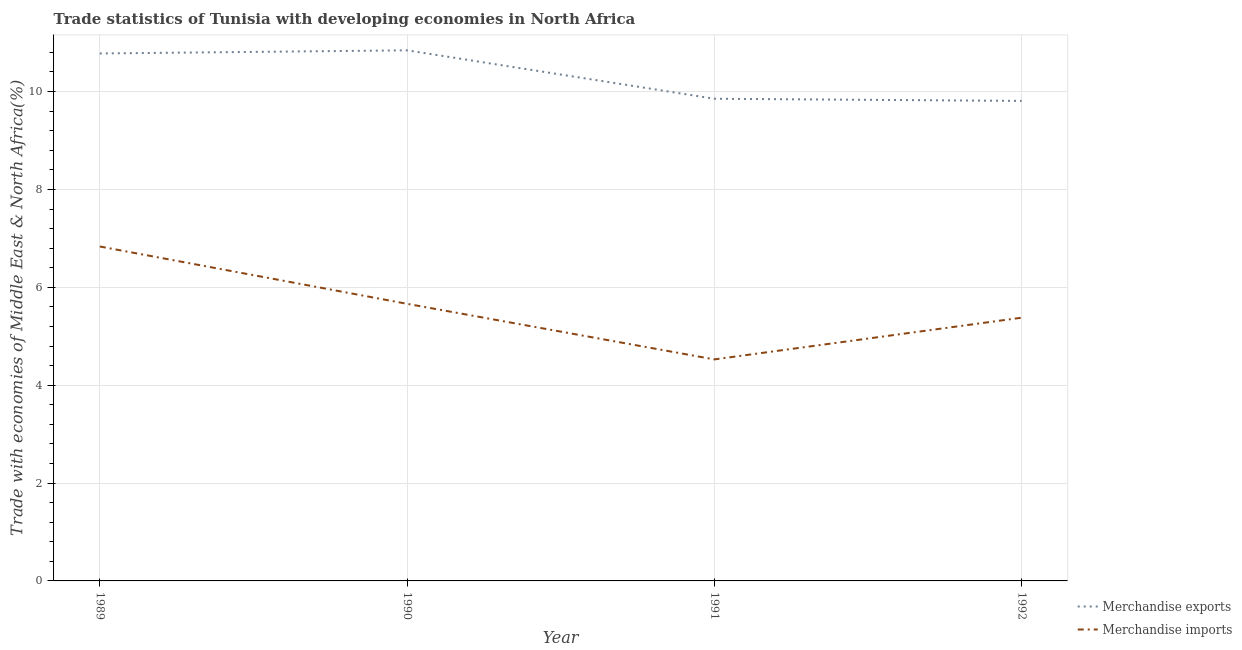What is the merchandise imports in 1991?
Keep it short and to the point. 4.53. Across all years, what is the maximum merchandise imports?
Give a very brief answer. 6.83. Across all years, what is the minimum merchandise exports?
Ensure brevity in your answer.  9.81. In which year was the merchandise imports maximum?
Your answer should be compact. 1989. In which year was the merchandise imports minimum?
Keep it short and to the point. 1991. What is the total merchandise imports in the graph?
Keep it short and to the point. 22.4. What is the difference between the merchandise imports in 1991 and that in 1992?
Offer a terse response. -0.85. What is the difference between the merchandise imports in 1991 and the merchandise exports in 1990?
Offer a very short reply. -6.32. What is the average merchandise exports per year?
Offer a very short reply. 10.32. In the year 1989, what is the difference between the merchandise imports and merchandise exports?
Keep it short and to the point. -3.94. What is the ratio of the merchandise imports in 1989 to that in 1992?
Offer a very short reply. 1.27. Is the difference between the merchandise imports in 1989 and 1992 greater than the difference between the merchandise exports in 1989 and 1992?
Your answer should be very brief. Yes. What is the difference between the highest and the second highest merchandise imports?
Offer a terse response. 1.17. What is the difference between the highest and the lowest merchandise imports?
Offer a very short reply. 2.31. In how many years, is the merchandise exports greater than the average merchandise exports taken over all years?
Keep it short and to the point. 2. Is the sum of the merchandise imports in 1989 and 1991 greater than the maximum merchandise exports across all years?
Give a very brief answer. Yes. Is the merchandise exports strictly less than the merchandise imports over the years?
Make the answer very short. No. How many lines are there?
Offer a terse response. 2. What is the difference between two consecutive major ticks on the Y-axis?
Provide a succinct answer. 2. Are the values on the major ticks of Y-axis written in scientific E-notation?
Your answer should be compact. No. Where does the legend appear in the graph?
Provide a short and direct response. Bottom right. How are the legend labels stacked?
Your answer should be compact. Vertical. What is the title of the graph?
Your answer should be compact. Trade statistics of Tunisia with developing economies in North Africa. Does "Primary education" appear as one of the legend labels in the graph?
Your answer should be very brief. No. What is the label or title of the Y-axis?
Keep it short and to the point. Trade with economies of Middle East & North Africa(%). What is the Trade with economies of Middle East & North Africa(%) of Merchandise exports in 1989?
Your response must be concise. 10.78. What is the Trade with economies of Middle East & North Africa(%) of Merchandise imports in 1989?
Ensure brevity in your answer.  6.83. What is the Trade with economies of Middle East & North Africa(%) of Merchandise exports in 1990?
Offer a very short reply. 10.84. What is the Trade with economies of Middle East & North Africa(%) of Merchandise imports in 1990?
Give a very brief answer. 5.66. What is the Trade with economies of Middle East & North Africa(%) of Merchandise exports in 1991?
Provide a short and direct response. 9.85. What is the Trade with economies of Middle East & North Africa(%) of Merchandise imports in 1991?
Offer a very short reply. 4.53. What is the Trade with economies of Middle East & North Africa(%) in Merchandise exports in 1992?
Offer a terse response. 9.81. What is the Trade with economies of Middle East & North Africa(%) of Merchandise imports in 1992?
Offer a terse response. 5.38. Across all years, what is the maximum Trade with economies of Middle East & North Africa(%) of Merchandise exports?
Provide a succinct answer. 10.84. Across all years, what is the maximum Trade with economies of Middle East & North Africa(%) in Merchandise imports?
Your answer should be very brief. 6.83. Across all years, what is the minimum Trade with economies of Middle East & North Africa(%) of Merchandise exports?
Your answer should be compact. 9.81. Across all years, what is the minimum Trade with economies of Middle East & North Africa(%) in Merchandise imports?
Make the answer very short. 4.53. What is the total Trade with economies of Middle East & North Africa(%) of Merchandise exports in the graph?
Your answer should be compact. 41.28. What is the total Trade with economies of Middle East & North Africa(%) in Merchandise imports in the graph?
Your answer should be very brief. 22.4. What is the difference between the Trade with economies of Middle East & North Africa(%) of Merchandise exports in 1989 and that in 1990?
Provide a succinct answer. -0.06. What is the difference between the Trade with economies of Middle East & North Africa(%) in Merchandise imports in 1989 and that in 1990?
Your answer should be very brief. 1.17. What is the difference between the Trade with economies of Middle East & North Africa(%) of Merchandise exports in 1989 and that in 1991?
Give a very brief answer. 0.93. What is the difference between the Trade with economies of Middle East & North Africa(%) of Merchandise imports in 1989 and that in 1991?
Your response must be concise. 2.31. What is the difference between the Trade with economies of Middle East & North Africa(%) of Merchandise exports in 1989 and that in 1992?
Your answer should be very brief. 0.97. What is the difference between the Trade with economies of Middle East & North Africa(%) of Merchandise imports in 1989 and that in 1992?
Provide a succinct answer. 1.45. What is the difference between the Trade with economies of Middle East & North Africa(%) in Merchandise imports in 1990 and that in 1991?
Make the answer very short. 1.14. What is the difference between the Trade with economies of Middle East & North Africa(%) of Merchandise exports in 1990 and that in 1992?
Ensure brevity in your answer.  1.03. What is the difference between the Trade with economies of Middle East & North Africa(%) in Merchandise imports in 1990 and that in 1992?
Keep it short and to the point. 0.28. What is the difference between the Trade with economies of Middle East & North Africa(%) in Merchandise exports in 1991 and that in 1992?
Keep it short and to the point. 0.04. What is the difference between the Trade with economies of Middle East & North Africa(%) in Merchandise imports in 1991 and that in 1992?
Ensure brevity in your answer.  -0.85. What is the difference between the Trade with economies of Middle East & North Africa(%) in Merchandise exports in 1989 and the Trade with economies of Middle East & North Africa(%) in Merchandise imports in 1990?
Provide a succinct answer. 5.12. What is the difference between the Trade with economies of Middle East & North Africa(%) of Merchandise exports in 1989 and the Trade with economies of Middle East & North Africa(%) of Merchandise imports in 1991?
Offer a very short reply. 6.25. What is the difference between the Trade with economies of Middle East & North Africa(%) in Merchandise exports in 1989 and the Trade with economies of Middle East & North Africa(%) in Merchandise imports in 1992?
Your answer should be very brief. 5.4. What is the difference between the Trade with economies of Middle East & North Africa(%) in Merchandise exports in 1990 and the Trade with economies of Middle East & North Africa(%) in Merchandise imports in 1991?
Give a very brief answer. 6.32. What is the difference between the Trade with economies of Middle East & North Africa(%) of Merchandise exports in 1990 and the Trade with economies of Middle East & North Africa(%) of Merchandise imports in 1992?
Your answer should be very brief. 5.46. What is the difference between the Trade with economies of Middle East & North Africa(%) of Merchandise exports in 1991 and the Trade with economies of Middle East & North Africa(%) of Merchandise imports in 1992?
Your answer should be very brief. 4.47. What is the average Trade with economies of Middle East & North Africa(%) of Merchandise exports per year?
Provide a short and direct response. 10.32. What is the average Trade with economies of Middle East & North Africa(%) of Merchandise imports per year?
Offer a very short reply. 5.6. In the year 1989, what is the difference between the Trade with economies of Middle East & North Africa(%) of Merchandise exports and Trade with economies of Middle East & North Africa(%) of Merchandise imports?
Provide a succinct answer. 3.94. In the year 1990, what is the difference between the Trade with economies of Middle East & North Africa(%) of Merchandise exports and Trade with economies of Middle East & North Africa(%) of Merchandise imports?
Make the answer very short. 5.18. In the year 1991, what is the difference between the Trade with economies of Middle East & North Africa(%) of Merchandise exports and Trade with economies of Middle East & North Africa(%) of Merchandise imports?
Provide a succinct answer. 5.33. In the year 1992, what is the difference between the Trade with economies of Middle East & North Africa(%) in Merchandise exports and Trade with economies of Middle East & North Africa(%) in Merchandise imports?
Provide a succinct answer. 4.43. What is the ratio of the Trade with economies of Middle East & North Africa(%) of Merchandise imports in 1989 to that in 1990?
Offer a terse response. 1.21. What is the ratio of the Trade with economies of Middle East & North Africa(%) of Merchandise exports in 1989 to that in 1991?
Ensure brevity in your answer.  1.09. What is the ratio of the Trade with economies of Middle East & North Africa(%) of Merchandise imports in 1989 to that in 1991?
Ensure brevity in your answer.  1.51. What is the ratio of the Trade with economies of Middle East & North Africa(%) of Merchandise exports in 1989 to that in 1992?
Offer a very short reply. 1.1. What is the ratio of the Trade with economies of Middle East & North Africa(%) of Merchandise imports in 1989 to that in 1992?
Provide a succinct answer. 1.27. What is the ratio of the Trade with economies of Middle East & North Africa(%) of Merchandise exports in 1990 to that in 1991?
Give a very brief answer. 1.1. What is the ratio of the Trade with economies of Middle East & North Africa(%) of Merchandise imports in 1990 to that in 1991?
Offer a terse response. 1.25. What is the ratio of the Trade with economies of Middle East & North Africa(%) in Merchandise exports in 1990 to that in 1992?
Provide a succinct answer. 1.11. What is the ratio of the Trade with economies of Middle East & North Africa(%) of Merchandise imports in 1990 to that in 1992?
Your response must be concise. 1.05. What is the ratio of the Trade with economies of Middle East & North Africa(%) of Merchandise exports in 1991 to that in 1992?
Ensure brevity in your answer.  1. What is the ratio of the Trade with economies of Middle East & North Africa(%) in Merchandise imports in 1991 to that in 1992?
Your answer should be very brief. 0.84. What is the difference between the highest and the second highest Trade with economies of Middle East & North Africa(%) of Merchandise exports?
Provide a succinct answer. 0.06. What is the difference between the highest and the second highest Trade with economies of Middle East & North Africa(%) in Merchandise imports?
Offer a very short reply. 1.17. What is the difference between the highest and the lowest Trade with economies of Middle East & North Africa(%) in Merchandise exports?
Offer a terse response. 1.03. What is the difference between the highest and the lowest Trade with economies of Middle East & North Africa(%) in Merchandise imports?
Provide a succinct answer. 2.31. 